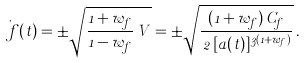<formula> <loc_0><loc_0><loc_500><loc_500>\dot { \ f } ( t ) = \pm \sqrt { \frac { 1 + w _ { f } } { 1 - w _ { f } } \, V } = \pm \sqrt { \frac { ( 1 + w _ { f } ) \, C _ { f } } { \, 2 \, [ a ( t ) ] ^ { 3 ( 1 + w _ { f } ) } } } \, .</formula> 